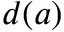<formula> <loc_0><loc_0><loc_500><loc_500>d ( a )</formula> 